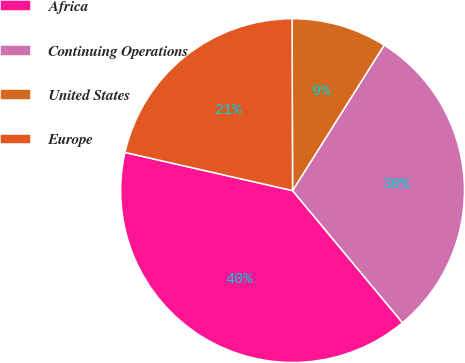<chart> <loc_0><loc_0><loc_500><loc_500><pie_chart><fcel>Africa<fcel>Continuing Operations<fcel>United States<fcel>Europe<nl><fcel>39.61%<fcel>30.01%<fcel>8.99%<fcel>21.39%<nl></chart> 